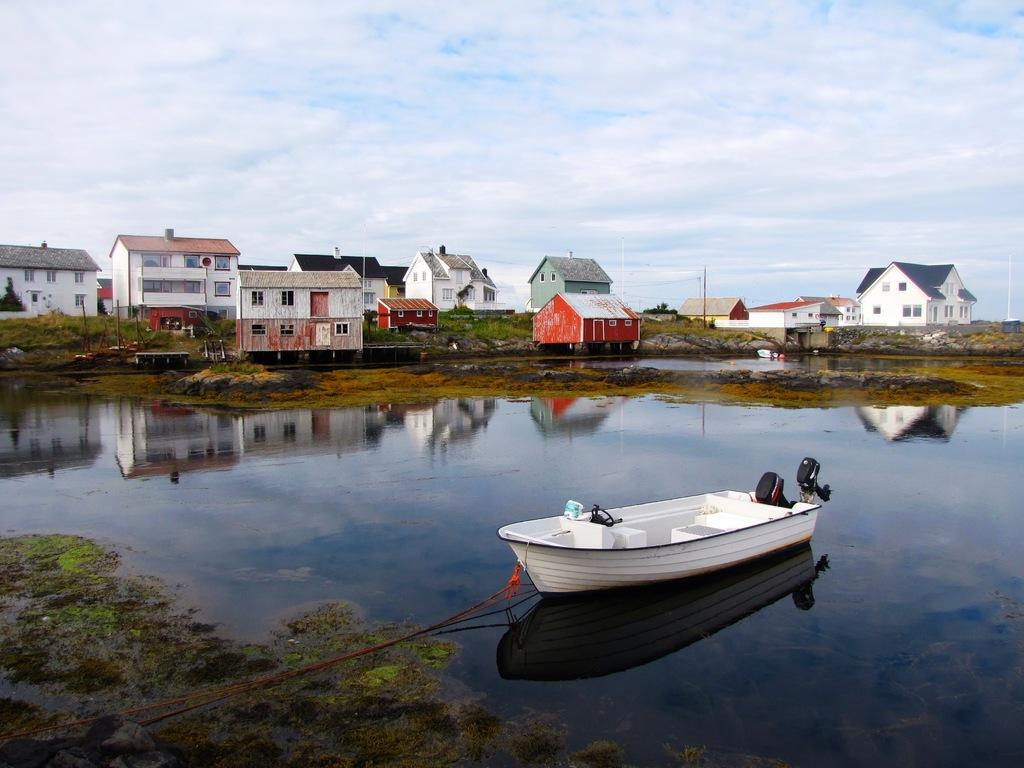What type of structures can be seen in the image? There are houses in the image. What is located in the water in the image? There is a boat in the water. How would you describe the sky in the image? The sky is blue and cloudy. What type of interest is being paid on the boat in the image? There is no mention of interest or any financial aspect related to the boat in the image. --- 